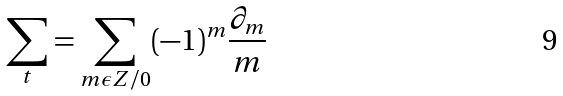Convert formula to latex. <formula><loc_0><loc_0><loc_500><loc_500>\sum _ { t } = \sum _ { m \epsilon Z / 0 } ( - 1 ) ^ { m } \frac { \partial _ { m } } { m }</formula> 